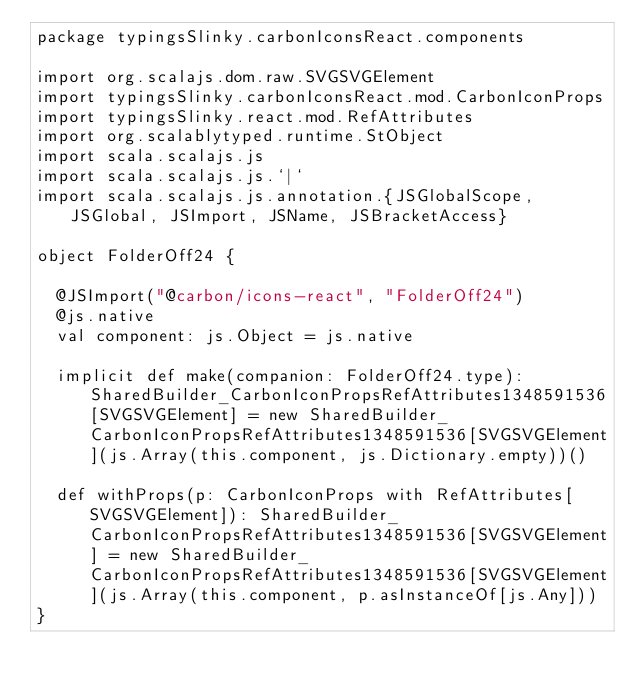<code> <loc_0><loc_0><loc_500><loc_500><_Scala_>package typingsSlinky.carbonIconsReact.components

import org.scalajs.dom.raw.SVGSVGElement
import typingsSlinky.carbonIconsReact.mod.CarbonIconProps
import typingsSlinky.react.mod.RefAttributes
import org.scalablytyped.runtime.StObject
import scala.scalajs.js
import scala.scalajs.js.`|`
import scala.scalajs.js.annotation.{JSGlobalScope, JSGlobal, JSImport, JSName, JSBracketAccess}

object FolderOff24 {
  
  @JSImport("@carbon/icons-react", "FolderOff24")
  @js.native
  val component: js.Object = js.native
  
  implicit def make(companion: FolderOff24.type): SharedBuilder_CarbonIconPropsRefAttributes1348591536[SVGSVGElement] = new SharedBuilder_CarbonIconPropsRefAttributes1348591536[SVGSVGElement](js.Array(this.component, js.Dictionary.empty))()
  
  def withProps(p: CarbonIconProps with RefAttributes[SVGSVGElement]): SharedBuilder_CarbonIconPropsRefAttributes1348591536[SVGSVGElement] = new SharedBuilder_CarbonIconPropsRefAttributes1348591536[SVGSVGElement](js.Array(this.component, p.asInstanceOf[js.Any]))
}
</code> 